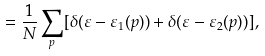<formula> <loc_0><loc_0><loc_500><loc_500>= \frac { 1 } { N } \sum _ { p } [ \delta ( \varepsilon - \varepsilon _ { 1 } ( { p } ) ) + \delta ( \varepsilon - \varepsilon _ { 2 } ( { p } ) ) ] ,</formula> 